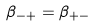<formula> <loc_0><loc_0><loc_500><loc_500>\beta _ { - + } = \beta _ { + - }</formula> 